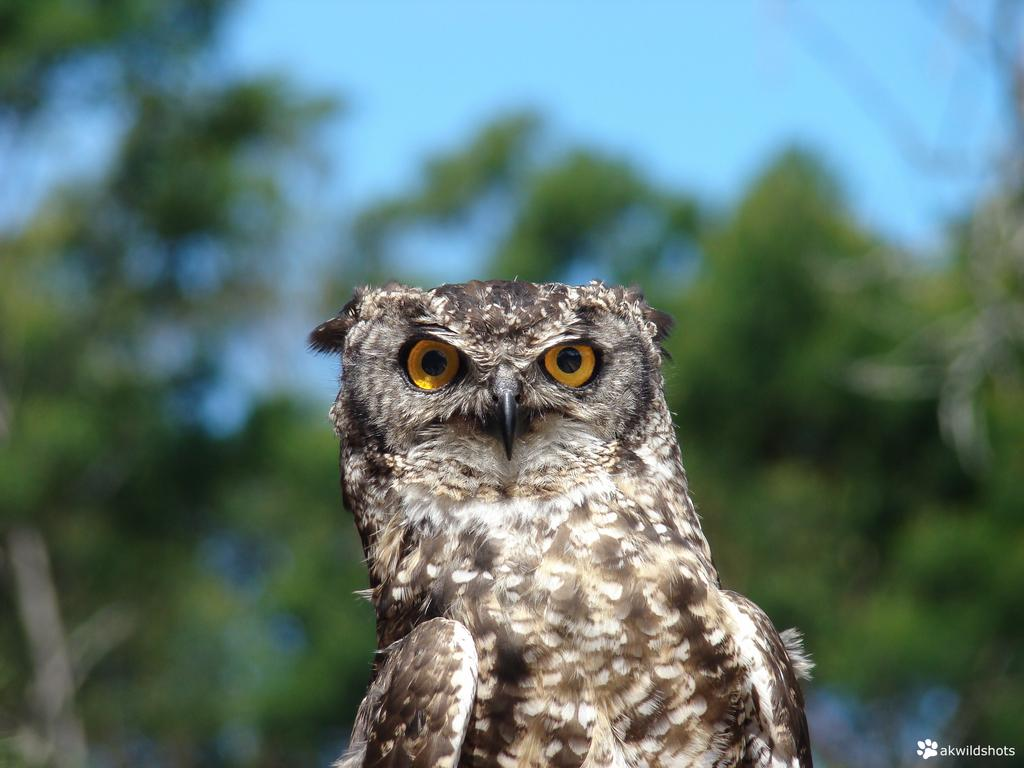What animal is the main subject of the image? There is an owl in the image. How would you describe the background of the image? The background of the image is blurry. What can be seen in the distance in the image? There are trees and the sky visible in the background of the image. Is there any text or marking on the image? Yes, there is a watermark at the bottom right side of the image. How many pets are visible in the image? There are no pets visible in the image; it features an owl. What type of door can be seen in the image? There is no door present in the image. 